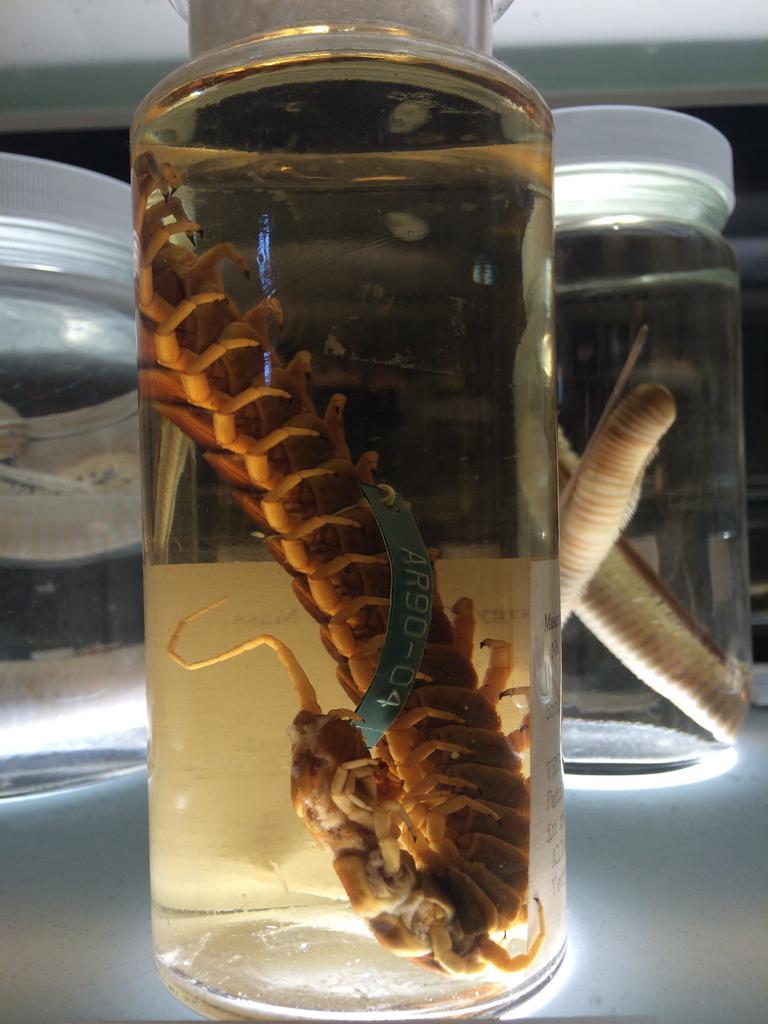How would you summarize this image in a sentence or two? The picture consists of three glass jars in which middle glass jar there is one centipede in the water and behind that there is another word placed on the table. 